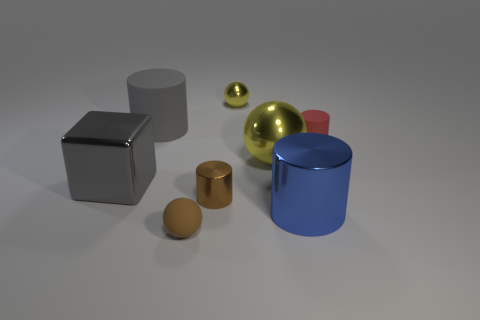What materials do the objects in the image appear to be made of? The objects exhibit diverse materials; the cube and the cylindrical container to the right seem metallic with reflective surfaces, the large ball seems like polished gold, the red sphere might be plastic, and the two smaller items appear matte, perhaps wooden or made of clay. 